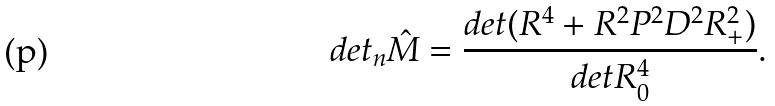<formula> <loc_0><loc_0><loc_500><loc_500>d e t _ { n } \hat { M } = \frac { d e t ( R ^ { 4 } + R ^ { 2 } P ^ { 2 } D ^ { 2 } R _ { + } ^ { 2 } ) } { d e t R _ { 0 } ^ { 4 } } .</formula> 